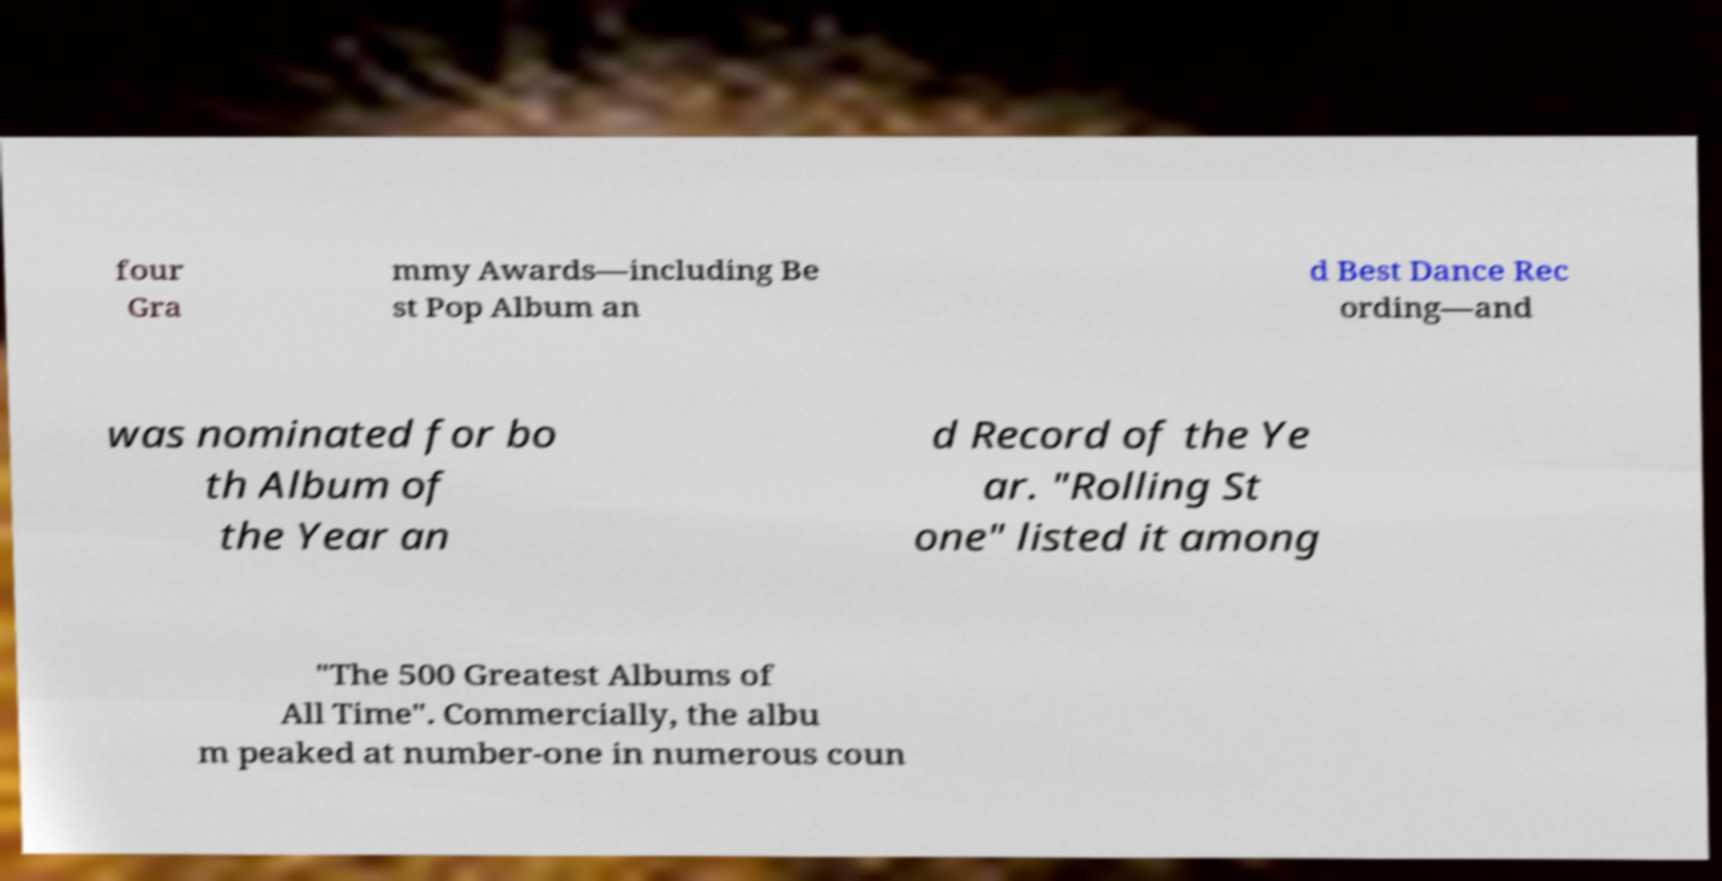I need the written content from this picture converted into text. Can you do that? four Gra mmy Awards—including Be st Pop Album an d Best Dance Rec ording—and was nominated for bo th Album of the Year an d Record of the Ye ar. "Rolling St one" listed it among "The 500 Greatest Albums of All Time". Commercially, the albu m peaked at number-one in numerous coun 